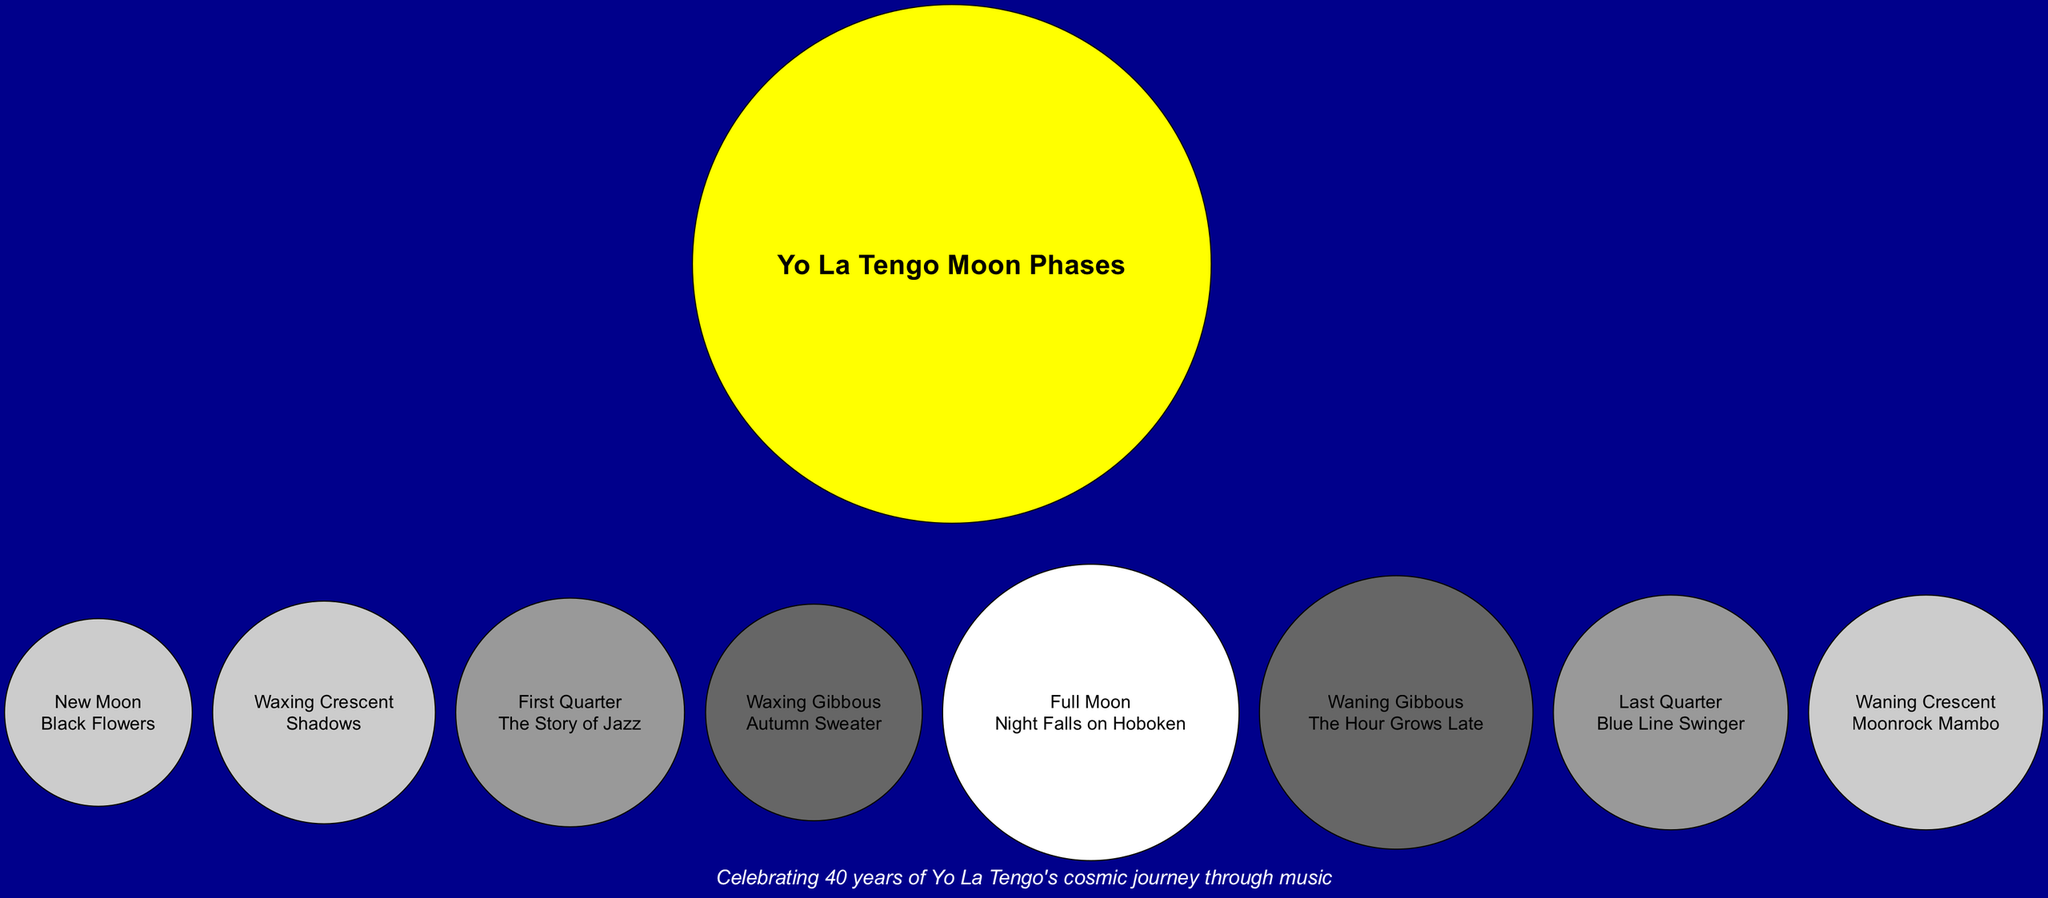What is the song associated with the Full Moon phase? The Full Moon phase is specifically labeled in the diagram, and it is linked to the song "Night Falls on Hoboken." This identification can be seen directly in the section for the Full Moon.
Answer: Night Falls on Hoboken How many moon phases are represented in the diagram? The diagram includes a total of eight distinct moon phases, each paired with a different song title. By counting the phases listed, you can ascertain their total number, which is eight.
Answer: 8 What is the color of the Waxing Crescent phase? The Waxing Crescent phase is shown in the diagram with the color gray80. This can be confirmed by looking at the color assigned specifically to that phase.
Answer: gray80 Which song corresponds to the Last Quarter phase? In reviewing the Last Quarter section of the diagram, it is clear that the song listed is "Blue Line Swinger." This is found directly next to the Last Quarter phase label.
Answer: Blue Line Swinger What is the relationship between the New Moon and its song? The New Moon is connected directly to the song "Black Flowers," indicated by its proximity in the diagram. This relationship is visually represented as a link between the New Moon phase and the song title.
Answer: Black Flowers Which moon phase is associated with the song "Shadows"? The song "Shadows" is associated with the Waxing Crescent phase. This can be found by locating the Waxing Crescent and noting the song title displayed next to it in the diagram.
Answer: Shadows What notes are included in the diagram? The note presented in the diagram is a recognition of "Celebrating 40 years of Yo La Tengo's cosmic journey through music." This note is typically found at the bottom of the diagram, providing context to the artwork.
Answer: Celebrating 40 years of Yo La Tengo's cosmic journey through music What color represents the Full Moon phase? The Full Moon phase is represented by the color white, which is specifically designated in the diagram to indicate its unique status among the phases.
Answer: white 